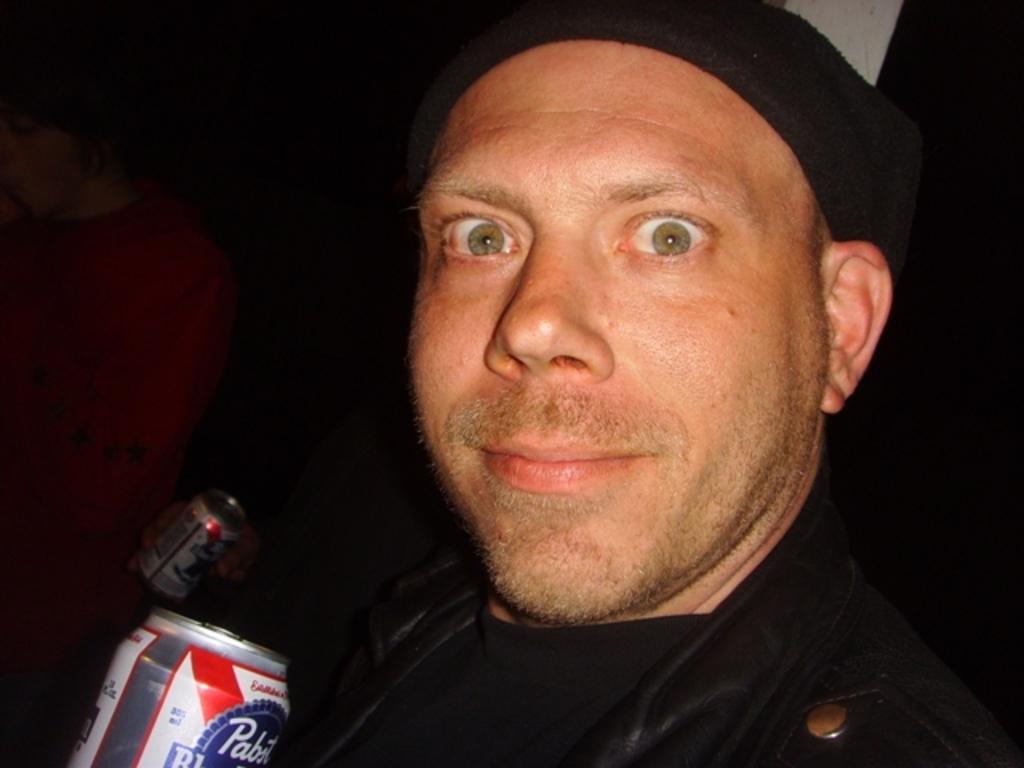How would you summarize this image in a sentence or two? In the picture we can see a man with a black jacket and holding a cool drink tin and beside him we can see another person with red dress and holding a tin. 